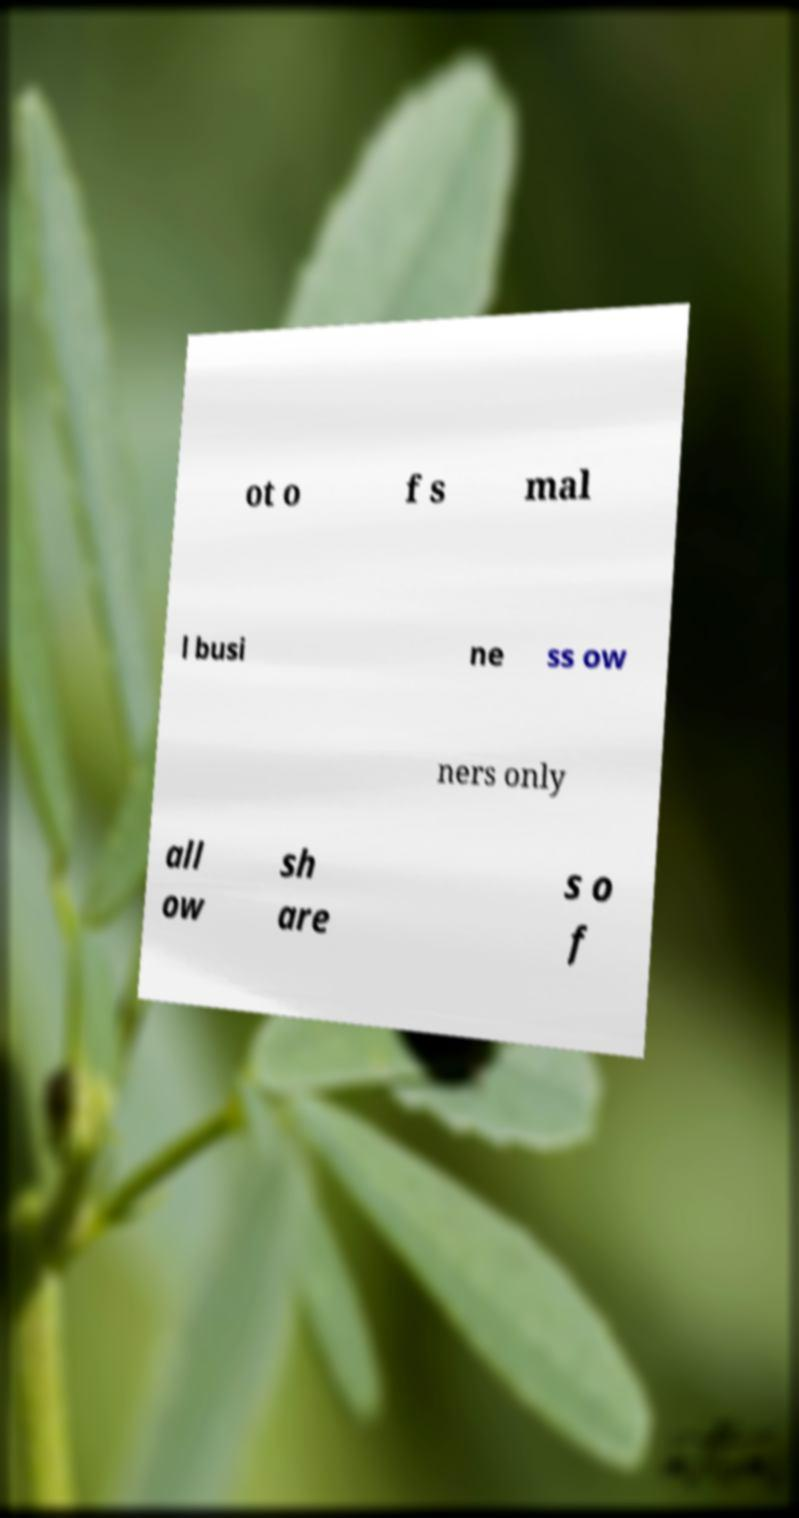For documentation purposes, I need the text within this image transcribed. Could you provide that? ot o f s mal l busi ne ss ow ners only all ow sh are s o f 